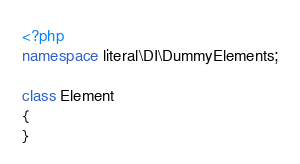<code> <loc_0><loc_0><loc_500><loc_500><_PHP_><?php
namespace literal\DI\DummyElements;

class Element
{
}
</code> 